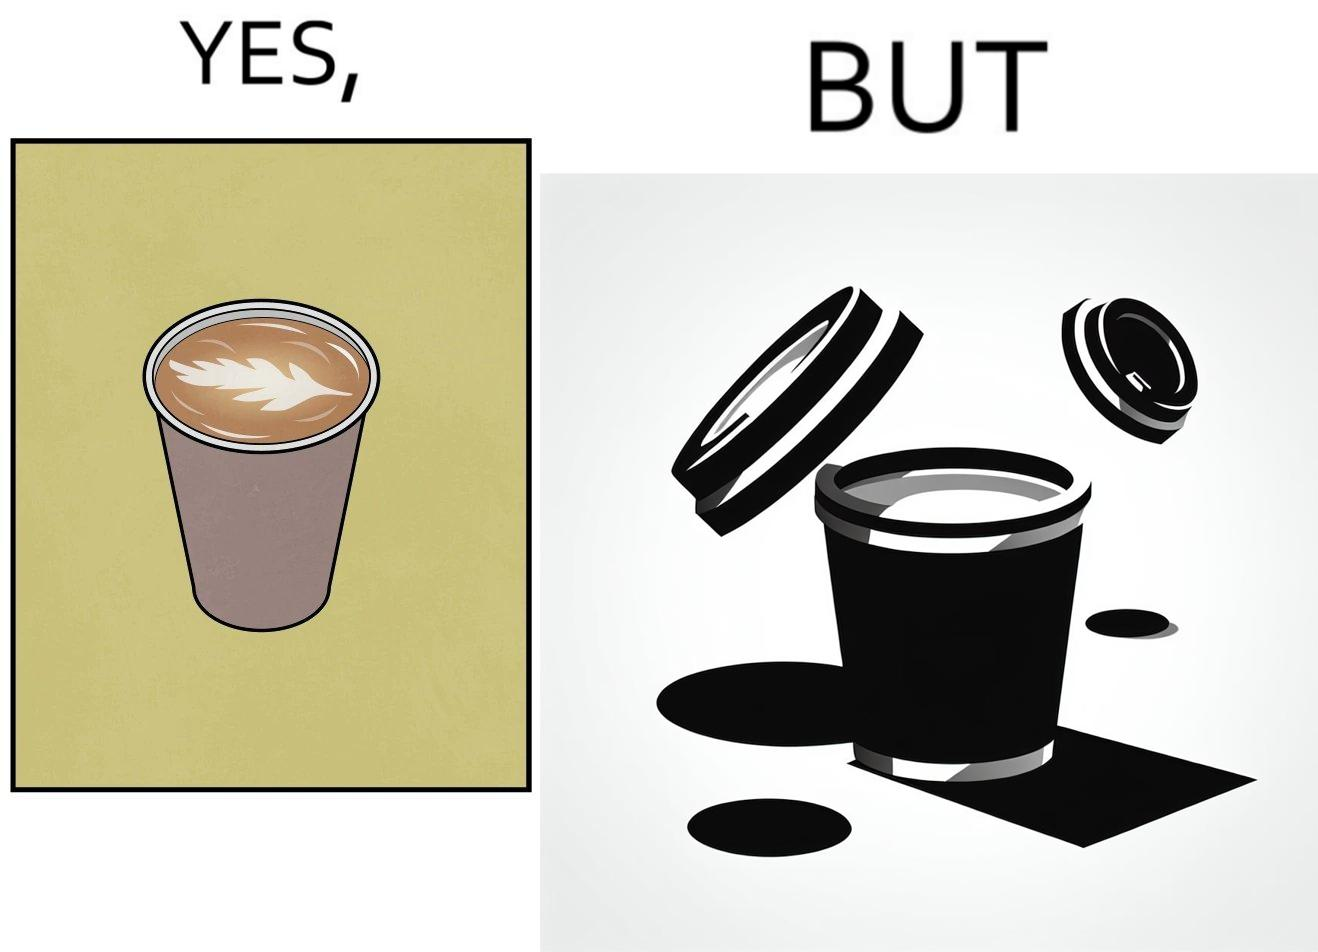Describe what you see in the left and right parts of this image. In the left part of the image: It is a cup of coffee with latte art In the right part of the image: It is a cup of coffee with its lid on top 